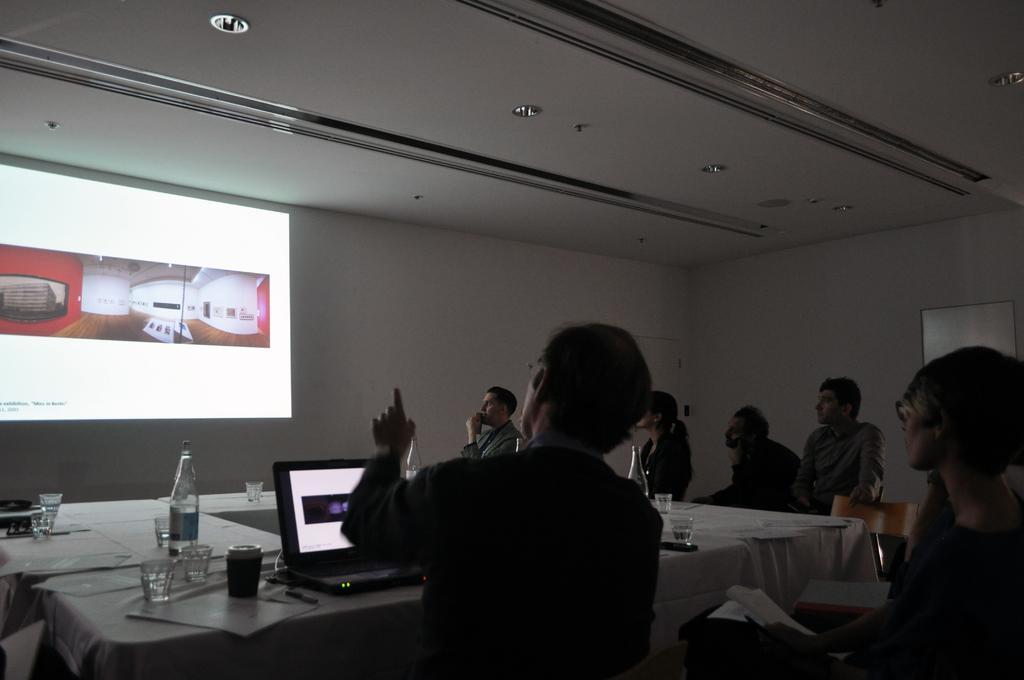Describe this image in one or two sentences. In this image we can see a few people gathered in a room and they are paying attention to this screen. There is a person sitting on a chair and he is explaining something on the screen. This is a table where a laptop, a bottle and glasses are kept on it. 